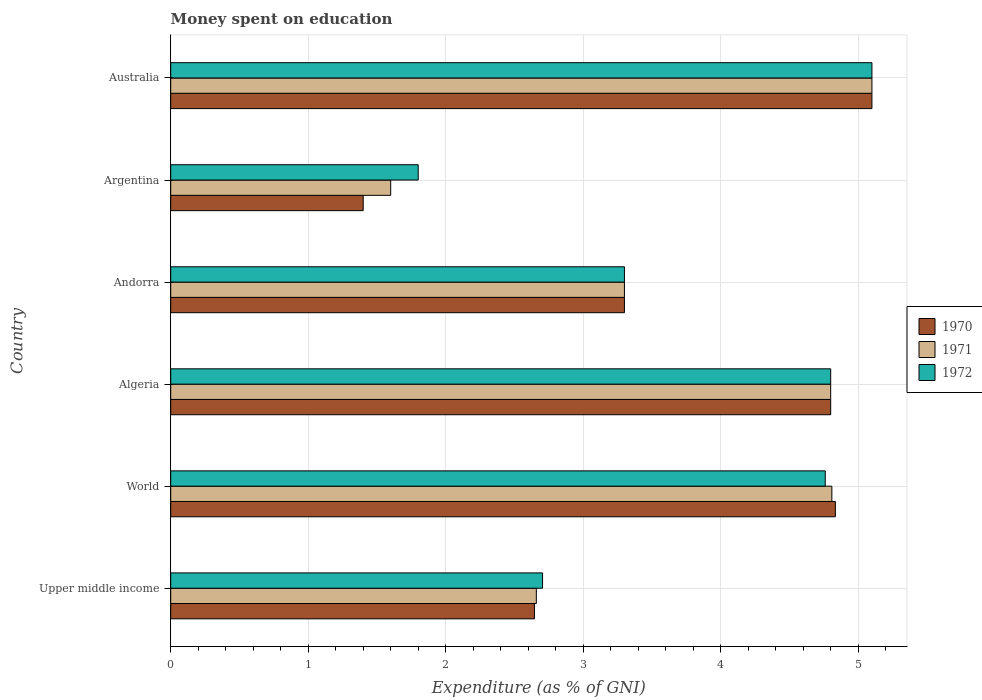How many groups of bars are there?
Keep it short and to the point. 6. Are the number of bars per tick equal to the number of legend labels?
Give a very brief answer. Yes. How many bars are there on the 3rd tick from the bottom?
Offer a terse response. 3. What is the label of the 1st group of bars from the top?
Provide a succinct answer. Australia. In how many cases, is the number of bars for a given country not equal to the number of legend labels?
Keep it short and to the point. 0. What is the amount of money spent on education in 1970 in Andorra?
Keep it short and to the point. 3.3. In which country was the amount of money spent on education in 1970 maximum?
Provide a succinct answer. Australia. What is the total amount of money spent on education in 1971 in the graph?
Give a very brief answer. 22.27. What is the difference between the amount of money spent on education in 1970 in Andorra and that in Australia?
Make the answer very short. -1.8. What is the difference between the amount of money spent on education in 1972 in Argentina and the amount of money spent on education in 1970 in World?
Keep it short and to the point. -3.03. What is the average amount of money spent on education in 1971 per country?
Give a very brief answer. 3.71. What is the ratio of the amount of money spent on education in 1972 in Andorra to that in Upper middle income?
Your response must be concise. 1.22. Is the amount of money spent on education in 1971 in Australia less than that in Upper middle income?
Your response must be concise. No. What is the difference between the highest and the second highest amount of money spent on education in 1972?
Your answer should be compact. 0.3. What is the difference between the highest and the lowest amount of money spent on education in 1971?
Ensure brevity in your answer.  3.5. In how many countries, is the amount of money spent on education in 1971 greater than the average amount of money spent on education in 1971 taken over all countries?
Keep it short and to the point. 3. What does the 3rd bar from the bottom in Upper middle income represents?
Your answer should be compact. 1972. Is it the case that in every country, the sum of the amount of money spent on education in 1972 and amount of money spent on education in 1971 is greater than the amount of money spent on education in 1970?
Offer a very short reply. Yes. How many countries are there in the graph?
Ensure brevity in your answer.  6. What is the difference between two consecutive major ticks on the X-axis?
Ensure brevity in your answer.  1. Does the graph contain any zero values?
Offer a very short reply. No. Does the graph contain grids?
Offer a terse response. Yes. How many legend labels are there?
Your answer should be very brief. 3. What is the title of the graph?
Your answer should be very brief. Money spent on education. Does "1969" appear as one of the legend labels in the graph?
Give a very brief answer. No. What is the label or title of the X-axis?
Keep it short and to the point. Expenditure (as % of GNI). What is the Expenditure (as % of GNI) of 1970 in Upper middle income?
Your answer should be compact. 2.65. What is the Expenditure (as % of GNI) in 1971 in Upper middle income?
Provide a succinct answer. 2.66. What is the Expenditure (as % of GNI) in 1972 in Upper middle income?
Your answer should be very brief. 2.7. What is the Expenditure (as % of GNI) of 1970 in World?
Offer a very short reply. 4.83. What is the Expenditure (as % of GNI) of 1971 in World?
Offer a terse response. 4.81. What is the Expenditure (as % of GNI) in 1972 in World?
Your answer should be compact. 4.76. What is the Expenditure (as % of GNI) in 1971 in Algeria?
Your answer should be compact. 4.8. What is the Expenditure (as % of GNI) in 1972 in Algeria?
Your response must be concise. 4.8. What is the Expenditure (as % of GNI) of 1972 in Andorra?
Make the answer very short. 3.3. What is the Expenditure (as % of GNI) in 1970 in Argentina?
Offer a very short reply. 1.4. What is the Expenditure (as % of GNI) in 1972 in Argentina?
Your response must be concise. 1.8. What is the Expenditure (as % of GNI) of 1970 in Australia?
Your answer should be compact. 5.1. What is the Expenditure (as % of GNI) in 1971 in Australia?
Give a very brief answer. 5.1. Across all countries, what is the minimum Expenditure (as % of GNI) of 1971?
Offer a very short reply. 1.6. What is the total Expenditure (as % of GNI) of 1970 in the graph?
Provide a succinct answer. 22.08. What is the total Expenditure (as % of GNI) of 1971 in the graph?
Keep it short and to the point. 22.27. What is the total Expenditure (as % of GNI) of 1972 in the graph?
Your response must be concise. 22.46. What is the difference between the Expenditure (as % of GNI) of 1970 in Upper middle income and that in World?
Provide a succinct answer. -2.19. What is the difference between the Expenditure (as % of GNI) in 1971 in Upper middle income and that in World?
Give a very brief answer. -2.15. What is the difference between the Expenditure (as % of GNI) in 1972 in Upper middle income and that in World?
Make the answer very short. -2.06. What is the difference between the Expenditure (as % of GNI) in 1970 in Upper middle income and that in Algeria?
Your answer should be very brief. -2.15. What is the difference between the Expenditure (as % of GNI) in 1971 in Upper middle income and that in Algeria?
Your answer should be compact. -2.14. What is the difference between the Expenditure (as % of GNI) of 1972 in Upper middle income and that in Algeria?
Make the answer very short. -2.1. What is the difference between the Expenditure (as % of GNI) of 1970 in Upper middle income and that in Andorra?
Your answer should be very brief. -0.65. What is the difference between the Expenditure (as % of GNI) in 1971 in Upper middle income and that in Andorra?
Your answer should be very brief. -0.64. What is the difference between the Expenditure (as % of GNI) in 1972 in Upper middle income and that in Andorra?
Your answer should be very brief. -0.6. What is the difference between the Expenditure (as % of GNI) in 1970 in Upper middle income and that in Argentina?
Your answer should be very brief. 1.25. What is the difference between the Expenditure (as % of GNI) of 1971 in Upper middle income and that in Argentina?
Keep it short and to the point. 1.06. What is the difference between the Expenditure (as % of GNI) in 1972 in Upper middle income and that in Argentina?
Your answer should be very brief. 0.9. What is the difference between the Expenditure (as % of GNI) in 1970 in Upper middle income and that in Australia?
Make the answer very short. -2.45. What is the difference between the Expenditure (as % of GNI) in 1971 in Upper middle income and that in Australia?
Offer a terse response. -2.44. What is the difference between the Expenditure (as % of GNI) in 1972 in Upper middle income and that in Australia?
Ensure brevity in your answer.  -2.4. What is the difference between the Expenditure (as % of GNI) of 1970 in World and that in Algeria?
Provide a succinct answer. 0.03. What is the difference between the Expenditure (as % of GNI) in 1971 in World and that in Algeria?
Your answer should be very brief. 0.01. What is the difference between the Expenditure (as % of GNI) of 1972 in World and that in Algeria?
Offer a very short reply. -0.04. What is the difference between the Expenditure (as % of GNI) in 1970 in World and that in Andorra?
Ensure brevity in your answer.  1.53. What is the difference between the Expenditure (as % of GNI) in 1971 in World and that in Andorra?
Offer a terse response. 1.51. What is the difference between the Expenditure (as % of GNI) in 1972 in World and that in Andorra?
Provide a short and direct response. 1.46. What is the difference between the Expenditure (as % of GNI) in 1970 in World and that in Argentina?
Make the answer very short. 3.43. What is the difference between the Expenditure (as % of GNI) in 1971 in World and that in Argentina?
Provide a succinct answer. 3.21. What is the difference between the Expenditure (as % of GNI) of 1972 in World and that in Argentina?
Your response must be concise. 2.96. What is the difference between the Expenditure (as % of GNI) of 1970 in World and that in Australia?
Your response must be concise. -0.27. What is the difference between the Expenditure (as % of GNI) of 1971 in World and that in Australia?
Give a very brief answer. -0.29. What is the difference between the Expenditure (as % of GNI) of 1972 in World and that in Australia?
Your answer should be very brief. -0.34. What is the difference between the Expenditure (as % of GNI) in 1971 in Algeria and that in Andorra?
Give a very brief answer. 1.5. What is the difference between the Expenditure (as % of GNI) of 1972 in Algeria and that in Andorra?
Your answer should be very brief. 1.5. What is the difference between the Expenditure (as % of GNI) in 1970 in Algeria and that in Argentina?
Provide a succinct answer. 3.4. What is the difference between the Expenditure (as % of GNI) in 1970 in Algeria and that in Australia?
Your response must be concise. -0.3. What is the difference between the Expenditure (as % of GNI) in 1971 in Andorra and that in Australia?
Provide a short and direct response. -1.8. What is the difference between the Expenditure (as % of GNI) in 1972 in Andorra and that in Australia?
Give a very brief answer. -1.8. What is the difference between the Expenditure (as % of GNI) of 1971 in Argentina and that in Australia?
Provide a succinct answer. -3.5. What is the difference between the Expenditure (as % of GNI) in 1972 in Argentina and that in Australia?
Keep it short and to the point. -3.3. What is the difference between the Expenditure (as % of GNI) in 1970 in Upper middle income and the Expenditure (as % of GNI) in 1971 in World?
Your answer should be very brief. -2.16. What is the difference between the Expenditure (as % of GNI) in 1970 in Upper middle income and the Expenditure (as % of GNI) in 1972 in World?
Offer a very short reply. -2.12. What is the difference between the Expenditure (as % of GNI) in 1971 in Upper middle income and the Expenditure (as % of GNI) in 1972 in World?
Keep it short and to the point. -2.1. What is the difference between the Expenditure (as % of GNI) in 1970 in Upper middle income and the Expenditure (as % of GNI) in 1971 in Algeria?
Offer a terse response. -2.15. What is the difference between the Expenditure (as % of GNI) of 1970 in Upper middle income and the Expenditure (as % of GNI) of 1972 in Algeria?
Your answer should be compact. -2.15. What is the difference between the Expenditure (as % of GNI) of 1971 in Upper middle income and the Expenditure (as % of GNI) of 1972 in Algeria?
Provide a short and direct response. -2.14. What is the difference between the Expenditure (as % of GNI) of 1970 in Upper middle income and the Expenditure (as % of GNI) of 1971 in Andorra?
Make the answer very short. -0.65. What is the difference between the Expenditure (as % of GNI) in 1970 in Upper middle income and the Expenditure (as % of GNI) in 1972 in Andorra?
Make the answer very short. -0.65. What is the difference between the Expenditure (as % of GNI) of 1971 in Upper middle income and the Expenditure (as % of GNI) of 1972 in Andorra?
Make the answer very short. -0.64. What is the difference between the Expenditure (as % of GNI) of 1970 in Upper middle income and the Expenditure (as % of GNI) of 1971 in Argentina?
Provide a succinct answer. 1.05. What is the difference between the Expenditure (as % of GNI) of 1970 in Upper middle income and the Expenditure (as % of GNI) of 1972 in Argentina?
Give a very brief answer. 0.85. What is the difference between the Expenditure (as % of GNI) of 1971 in Upper middle income and the Expenditure (as % of GNI) of 1972 in Argentina?
Ensure brevity in your answer.  0.86. What is the difference between the Expenditure (as % of GNI) of 1970 in Upper middle income and the Expenditure (as % of GNI) of 1971 in Australia?
Your answer should be very brief. -2.45. What is the difference between the Expenditure (as % of GNI) in 1970 in Upper middle income and the Expenditure (as % of GNI) in 1972 in Australia?
Provide a short and direct response. -2.45. What is the difference between the Expenditure (as % of GNI) in 1971 in Upper middle income and the Expenditure (as % of GNI) in 1972 in Australia?
Ensure brevity in your answer.  -2.44. What is the difference between the Expenditure (as % of GNI) in 1970 in World and the Expenditure (as % of GNI) in 1971 in Algeria?
Make the answer very short. 0.03. What is the difference between the Expenditure (as % of GNI) of 1970 in World and the Expenditure (as % of GNI) of 1972 in Algeria?
Keep it short and to the point. 0.03. What is the difference between the Expenditure (as % of GNI) in 1971 in World and the Expenditure (as % of GNI) in 1972 in Algeria?
Your response must be concise. 0.01. What is the difference between the Expenditure (as % of GNI) of 1970 in World and the Expenditure (as % of GNI) of 1971 in Andorra?
Offer a very short reply. 1.53. What is the difference between the Expenditure (as % of GNI) in 1970 in World and the Expenditure (as % of GNI) in 1972 in Andorra?
Provide a short and direct response. 1.53. What is the difference between the Expenditure (as % of GNI) of 1971 in World and the Expenditure (as % of GNI) of 1972 in Andorra?
Make the answer very short. 1.51. What is the difference between the Expenditure (as % of GNI) in 1970 in World and the Expenditure (as % of GNI) in 1971 in Argentina?
Give a very brief answer. 3.23. What is the difference between the Expenditure (as % of GNI) in 1970 in World and the Expenditure (as % of GNI) in 1972 in Argentina?
Your response must be concise. 3.03. What is the difference between the Expenditure (as % of GNI) of 1971 in World and the Expenditure (as % of GNI) of 1972 in Argentina?
Give a very brief answer. 3.01. What is the difference between the Expenditure (as % of GNI) of 1970 in World and the Expenditure (as % of GNI) of 1971 in Australia?
Your answer should be very brief. -0.27. What is the difference between the Expenditure (as % of GNI) in 1970 in World and the Expenditure (as % of GNI) in 1972 in Australia?
Offer a terse response. -0.27. What is the difference between the Expenditure (as % of GNI) in 1971 in World and the Expenditure (as % of GNI) in 1972 in Australia?
Your answer should be very brief. -0.29. What is the difference between the Expenditure (as % of GNI) in 1970 in Algeria and the Expenditure (as % of GNI) in 1971 in Andorra?
Provide a short and direct response. 1.5. What is the difference between the Expenditure (as % of GNI) of 1970 in Algeria and the Expenditure (as % of GNI) of 1972 in Andorra?
Keep it short and to the point. 1.5. What is the difference between the Expenditure (as % of GNI) in 1970 in Algeria and the Expenditure (as % of GNI) in 1972 in Argentina?
Your answer should be compact. 3. What is the difference between the Expenditure (as % of GNI) in 1971 in Algeria and the Expenditure (as % of GNI) in 1972 in Argentina?
Keep it short and to the point. 3. What is the difference between the Expenditure (as % of GNI) in 1970 in Algeria and the Expenditure (as % of GNI) in 1971 in Australia?
Keep it short and to the point. -0.3. What is the difference between the Expenditure (as % of GNI) in 1970 in Algeria and the Expenditure (as % of GNI) in 1972 in Australia?
Your response must be concise. -0.3. What is the difference between the Expenditure (as % of GNI) of 1971 in Andorra and the Expenditure (as % of GNI) of 1972 in Argentina?
Make the answer very short. 1.5. What is the difference between the Expenditure (as % of GNI) of 1970 in Andorra and the Expenditure (as % of GNI) of 1972 in Australia?
Your answer should be very brief. -1.8. What is the difference between the Expenditure (as % of GNI) of 1971 in Andorra and the Expenditure (as % of GNI) of 1972 in Australia?
Your answer should be compact. -1.8. What is the difference between the Expenditure (as % of GNI) of 1971 in Argentina and the Expenditure (as % of GNI) of 1972 in Australia?
Give a very brief answer. -3.5. What is the average Expenditure (as % of GNI) in 1970 per country?
Ensure brevity in your answer.  3.68. What is the average Expenditure (as % of GNI) of 1971 per country?
Provide a succinct answer. 3.71. What is the average Expenditure (as % of GNI) of 1972 per country?
Your answer should be compact. 3.74. What is the difference between the Expenditure (as % of GNI) of 1970 and Expenditure (as % of GNI) of 1971 in Upper middle income?
Make the answer very short. -0.01. What is the difference between the Expenditure (as % of GNI) in 1970 and Expenditure (as % of GNI) in 1972 in Upper middle income?
Your answer should be compact. -0.06. What is the difference between the Expenditure (as % of GNI) of 1971 and Expenditure (as % of GNI) of 1972 in Upper middle income?
Your answer should be very brief. -0.05. What is the difference between the Expenditure (as % of GNI) of 1970 and Expenditure (as % of GNI) of 1971 in World?
Your response must be concise. 0.03. What is the difference between the Expenditure (as % of GNI) of 1970 and Expenditure (as % of GNI) of 1972 in World?
Provide a short and direct response. 0.07. What is the difference between the Expenditure (as % of GNI) in 1971 and Expenditure (as % of GNI) in 1972 in World?
Provide a succinct answer. 0.05. What is the difference between the Expenditure (as % of GNI) of 1970 and Expenditure (as % of GNI) of 1972 in Algeria?
Offer a very short reply. 0. What is the difference between the Expenditure (as % of GNI) in 1971 and Expenditure (as % of GNI) in 1972 in Algeria?
Your answer should be compact. 0. What is the difference between the Expenditure (as % of GNI) in 1970 and Expenditure (as % of GNI) in 1972 in Andorra?
Your response must be concise. 0. What is the difference between the Expenditure (as % of GNI) in 1970 and Expenditure (as % of GNI) in 1972 in Argentina?
Provide a succinct answer. -0.4. What is the difference between the Expenditure (as % of GNI) of 1971 and Expenditure (as % of GNI) of 1972 in Argentina?
Provide a short and direct response. -0.2. What is the difference between the Expenditure (as % of GNI) in 1970 and Expenditure (as % of GNI) in 1972 in Australia?
Offer a very short reply. 0. What is the ratio of the Expenditure (as % of GNI) of 1970 in Upper middle income to that in World?
Make the answer very short. 0.55. What is the ratio of the Expenditure (as % of GNI) of 1971 in Upper middle income to that in World?
Offer a very short reply. 0.55. What is the ratio of the Expenditure (as % of GNI) in 1972 in Upper middle income to that in World?
Offer a very short reply. 0.57. What is the ratio of the Expenditure (as % of GNI) of 1970 in Upper middle income to that in Algeria?
Offer a terse response. 0.55. What is the ratio of the Expenditure (as % of GNI) in 1971 in Upper middle income to that in Algeria?
Your response must be concise. 0.55. What is the ratio of the Expenditure (as % of GNI) of 1972 in Upper middle income to that in Algeria?
Provide a succinct answer. 0.56. What is the ratio of the Expenditure (as % of GNI) in 1970 in Upper middle income to that in Andorra?
Provide a short and direct response. 0.8. What is the ratio of the Expenditure (as % of GNI) of 1971 in Upper middle income to that in Andorra?
Provide a short and direct response. 0.81. What is the ratio of the Expenditure (as % of GNI) in 1972 in Upper middle income to that in Andorra?
Your answer should be very brief. 0.82. What is the ratio of the Expenditure (as % of GNI) in 1970 in Upper middle income to that in Argentina?
Give a very brief answer. 1.89. What is the ratio of the Expenditure (as % of GNI) of 1971 in Upper middle income to that in Argentina?
Make the answer very short. 1.66. What is the ratio of the Expenditure (as % of GNI) in 1972 in Upper middle income to that in Argentina?
Provide a short and direct response. 1.5. What is the ratio of the Expenditure (as % of GNI) of 1970 in Upper middle income to that in Australia?
Keep it short and to the point. 0.52. What is the ratio of the Expenditure (as % of GNI) in 1971 in Upper middle income to that in Australia?
Provide a succinct answer. 0.52. What is the ratio of the Expenditure (as % of GNI) of 1972 in Upper middle income to that in Australia?
Offer a terse response. 0.53. What is the ratio of the Expenditure (as % of GNI) of 1970 in World to that in Algeria?
Give a very brief answer. 1.01. What is the ratio of the Expenditure (as % of GNI) of 1972 in World to that in Algeria?
Provide a succinct answer. 0.99. What is the ratio of the Expenditure (as % of GNI) in 1970 in World to that in Andorra?
Your answer should be compact. 1.46. What is the ratio of the Expenditure (as % of GNI) in 1971 in World to that in Andorra?
Your answer should be compact. 1.46. What is the ratio of the Expenditure (as % of GNI) of 1972 in World to that in Andorra?
Make the answer very short. 1.44. What is the ratio of the Expenditure (as % of GNI) in 1970 in World to that in Argentina?
Your answer should be compact. 3.45. What is the ratio of the Expenditure (as % of GNI) of 1971 in World to that in Argentina?
Make the answer very short. 3.01. What is the ratio of the Expenditure (as % of GNI) in 1972 in World to that in Argentina?
Offer a terse response. 2.64. What is the ratio of the Expenditure (as % of GNI) of 1970 in World to that in Australia?
Give a very brief answer. 0.95. What is the ratio of the Expenditure (as % of GNI) in 1971 in World to that in Australia?
Ensure brevity in your answer.  0.94. What is the ratio of the Expenditure (as % of GNI) in 1972 in World to that in Australia?
Ensure brevity in your answer.  0.93. What is the ratio of the Expenditure (as % of GNI) in 1970 in Algeria to that in Andorra?
Give a very brief answer. 1.45. What is the ratio of the Expenditure (as % of GNI) of 1971 in Algeria to that in Andorra?
Make the answer very short. 1.45. What is the ratio of the Expenditure (as % of GNI) in 1972 in Algeria to that in Andorra?
Your answer should be very brief. 1.45. What is the ratio of the Expenditure (as % of GNI) in 1970 in Algeria to that in Argentina?
Offer a very short reply. 3.43. What is the ratio of the Expenditure (as % of GNI) of 1971 in Algeria to that in Argentina?
Offer a terse response. 3. What is the ratio of the Expenditure (as % of GNI) in 1972 in Algeria to that in Argentina?
Provide a short and direct response. 2.67. What is the ratio of the Expenditure (as % of GNI) in 1972 in Algeria to that in Australia?
Keep it short and to the point. 0.94. What is the ratio of the Expenditure (as % of GNI) of 1970 in Andorra to that in Argentina?
Give a very brief answer. 2.36. What is the ratio of the Expenditure (as % of GNI) in 1971 in Andorra to that in Argentina?
Offer a very short reply. 2.06. What is the ratio of the Expenditure (as % of GNI) in 1972 in Andorra to that in Argentina?
Offer a terse response. 1.83. What is the ratio of the Expenditure (as % of GNI) of 1970 in Andorra to that in Australia?
Your answer should be very brief. 0.65. What is the ratio of the Expenditure (as % of GNI) in 1971 in Andorra to that in Australia?
Your answer should be very brief. 0.65. What is the ratio of the Expenditure (as % of GNI) of 1972 in Andorra to that in Australia?
Offer a terse response. 0.65. What is the ratio of the Expenditure (as % of GNI) in 1970 in Argentina to that in Australia?
Your answer should be very brief. 0.27. What is the ratio of the Expenditure (as % of GNI) of 1971 in Argentina to that in Australia?
Give a very brief answer. 0.31. What is the ratio of the Expenditure (as % of GNI) in 1972 in Argentina to that in Australia?
Provide a succinct answer. 0.35. What is the difference between the highest and the second highest Expenditure (as % of GNI) of 1970?
Your answer should be very brief. 0.27. What is the difference between the highest and the second highest Expenditure (as % of GNI) of 1971?
Keep it short and to the point. 0.29. What is the difference between the highest and the lowest Expenditure (as % of GNI) of 1970?
Give a very brief answer. 3.7. What is the difference between the highest and the lowest Expenditure (as % of GNI) of 1971?
Your response must be concise. 3.5. What is the difference between the highest and the lowest Expenditure (as % of GNI) in 1972?
Offer a terse response. 3.3. 